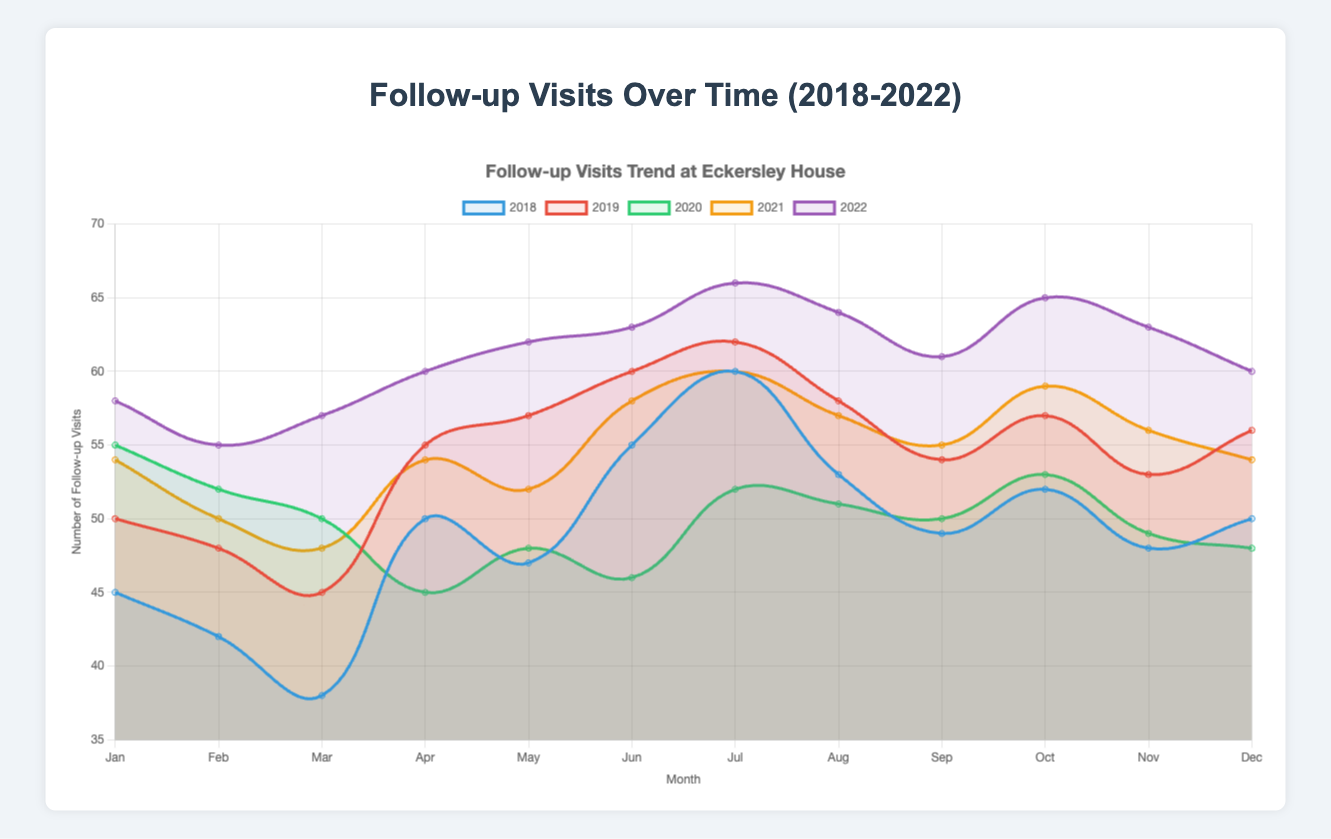How many follow-up visits were there in July 2022 and how does that compare to July 2021? To find the number of follow-up visits in July 2022, look at the line corresponding to the year 2022 and find the data point for July. Do the same for 2021. The value for July 2022 is 66, and for July 2021, it is 60. Comparing these values, 66 is greater than 60, indicating an increase in follow-up visits from 2021 to 2022.
Answer: 66, 60 Which year had the highest number of follow-up visits in December? Examine the data points for December across all years. The values are 50 (2018), 56 (2019), 48 (2020), 54 (2021), and 60 (2022). The highest value is 60, which occurred in 2022.
Answer: 2022 What is the average number of follow-up visits in May for the years 2018-2022? To calculate the average, sum the number of visits in May for all years and divide by the number of years. The values are 47 (2018), 57 (2019), 48 (2020), 52 (2021), and 62 (2022). Thus, the sum is 47 + 57 + 48 + 52 + 62 = 266, and the average is 266/5 = 53.2.
Answer: 53.2 In which month and year did the lowest number of follow-up visits occur? Examine all the data points across all months and years. The lowest value is 38, which occurred in March 2018.
Answer: March 2018 What is the trend in the number of follow-up visits from January to December in 2020? Follow the line representing the year 2020 from January to December. In January, the number of visits is 55, then it decreases to 52 in February, 50 in March, and 45 in April. Thereafter, some fluctuations occur: it increases to 48 in May, decreases to 46 in June, increases again to 52 in July, 51 in August, 50 in September, 53 in October, drops to 49 in November, and finally to 48 in December. Overall, the trend shows significant fluctuations with an initial decrease followed by smaller variations.
Answer: Fluctuating trend 